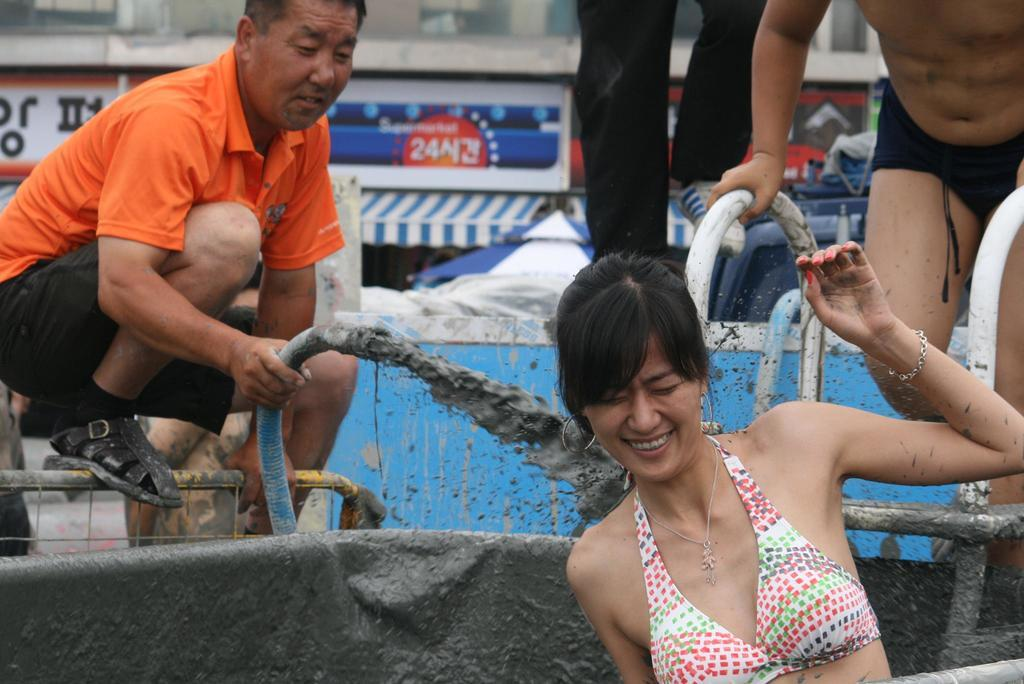What are the persons in the image wearing? The persons in the image are wearing clothes. What are the two persons holding in their hands? The two persons are holding pipes in their hands. What type of sack can be seen in the image? There is no sack present in the image. What kind of band is playing music in the image? There is no band or music present in the image. 